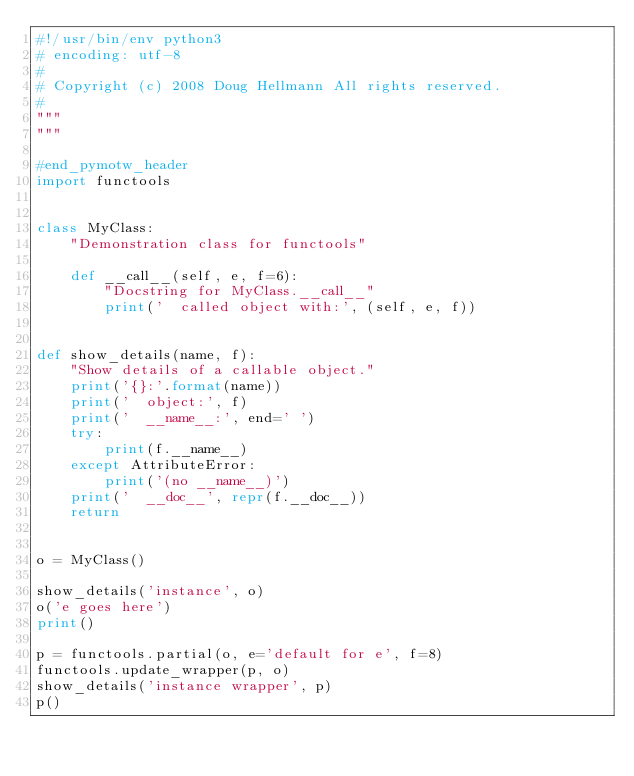<code> <loc_0><loc_0><loc_500><loc_500><_Python_>#!/usr/bin/env python3
# encoding: utf-8
#
# Copyright (c) 2008 Doug Hellmann All rights reserved.
#
"""
"""

#end_pymotw_header
import functools


class MyClass:
    "Demonstration class for functools"

    def __call__(self, e, f=6):
        "Docstring for MyClass.__call__"
        print('  called object with:', (self, e, f))


def show_details(name, f):
    "Show details of a callable object."
    print('{}:'.format(name))
    print('  object:', f)
    print('  __name__:', end=' ')
    try:
        print(f.__name__)
    except AttributeError:
        print('(no __name__)')
    print('  __doc__', repr(f.__doc__))
    return


o = MyClass()

show_details('instance', o)
o('e goes here')
print()

p = functools.partial(o, e='default for e', f=8)
functools.update_wrapper(p, o)
show_details('instance wrapper', p)
p()
</code> 